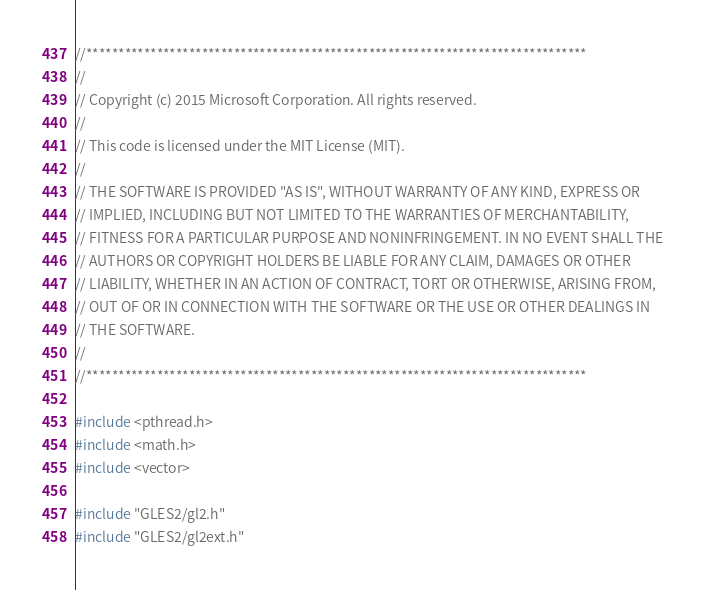Convert code to text. <code><loc_0><loc_0><loc_500><loc_500><_ObjectiveC_>//******************************************************************************
//
// Copyright (c) 2015 Microsoft Corporation. All rights reserved.
//
// This code is licensed under the MIT License (MIT).
//
// THE SOFTWARE IS PROVIDED "AS IS", WITHOUT WARRANTY OF ANY KIND, EXPRESS OR
// IMPLIED, INCLUDING BUT NOT LIMITED TO THE WARRANTIES OF MERCHANTABILITY,
// FITNESS FOR A PARTICULAR PURPOSE AND NONINFRINGEMENT. IN NO EVENT SHALL THE
// AUTHORS OR COPYRIGHT HOLDERS BE LIABLE FOR ANY CLAIM, DAMAGES OR OTHER
// LIABILITY, WHETHER IN AN ACTION OF CONTRACT, TORT OR OTHERWISE, ARISING FROM,
// OUT OF OR IN CONNECTION WITH THE SOFTWARE OR THE USE OR OTHER DEALINGS IN
// THE SOFTWARE.
//
//******************************************************************************

#include <pthread.h>
#include <math.h>
#include <vector>

#include "GLES2/gl2.h"
#include "GLES2/gl2ext.h"
</code> 